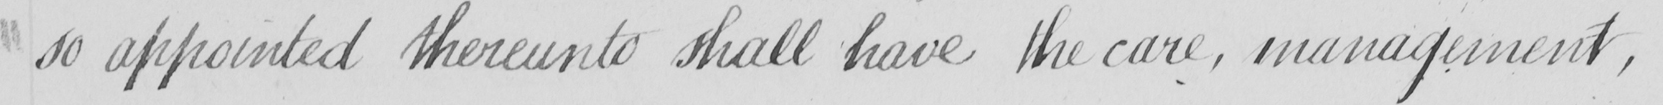Transcribe the text shown in this historical manuscript line. so appointed thereunto shall have the care , management , 